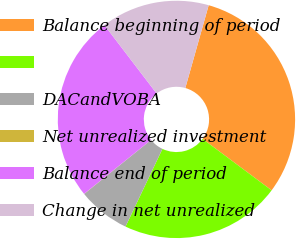Convert chart to OTSL. <chart><loc_0><loc_0><loc_500><loc_500><pie_chart><fcel>Balance beginning of period<fcel>Unnamed: 1<fcel>DACandVOBA<fcel>Net unrealized investment<fcel>Balance end of period<fcel>Change in net unrealized<nl><fcel>30.82%<fcel>21.87%<fcel>7.12%<fcel>0.02%<fcel>25.42%<fcel>14.76%<nl></chart> 